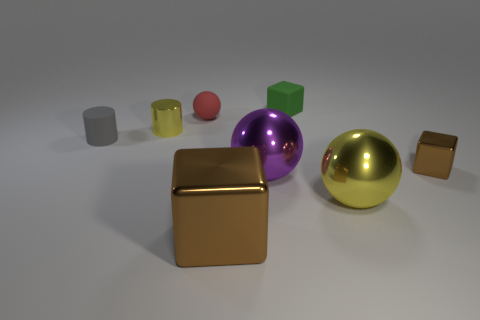There is a large metallic thing that is the same color as the tiny metal cube; what shape is it?
Make the answer very short. Cube. The gray object that is the same shape as the small yellow shiny thing is what size?
Ensure brevity in your answer.  Small. What number of other things are there of the same material as the small brown cube
Your response must be concise. 4. Is the number of tiny metallic cylinders that are left of the small gray cylinder the same as the number of brown metal things?
Give a very brief answer. No. There is a gray cylinder; is it the same size as the yellow thing that is in front of the matte cylinder?
Offer a terse response. No. What shape is the small metallic thing to the right of the tiny red object?
Offer a terse response. Cube. Is there a cyan matte ball?
Ensure brevity in your answer.  No. There is a rubber thing that is on the right side of the large brown metal object; is its size the same as the yellow object right of the red object?
Provide a short and direct response. No. The cube that is behind the large metallic block and in front of the red rubber thing is made of what material?
Your answer should be compact. Metal. What number of yellow cylinders are right of the green matte object?
Your answer should be very brief. 0. 